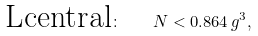Convert formula to latex. <formula><loc_0><loc_0><loc_500><loc_500>\text {Lcentral} \colon \quad N < 0 . 8 6 4 \, g ^ { 3 } ,</formula> 